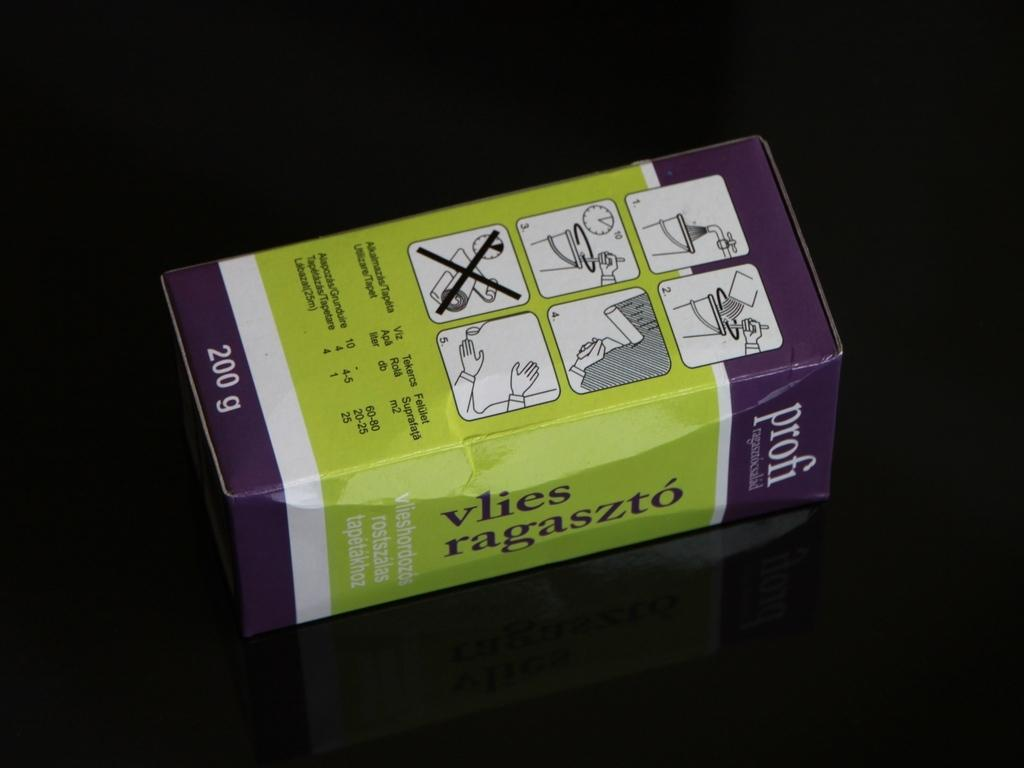Provide a one-sentence caption for the provided image. A 200 gram purple ad green box of profi vlies ragaszto sits on a black table. 